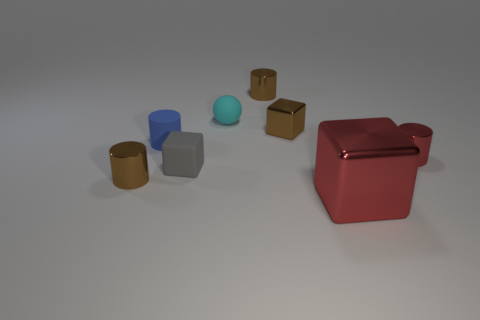Is there anything else that is the same size as the red block?
Give a very brief answer. No. There is a cylinder that is the same color as the large object; what is its size?
Your answer should be very brief. Small. How many other things are the same size as the red block?
Make the answer very short. 0. What color is the tiny metal cylinder left of the sphere?
Ensure brevity in your answer.  Brown. Is the material of the blue object left of the red shiny cylinder the same as the large red cube?
Provide a short and direct response. No. What number of cubes are in front of the tiny red metallic object and on the left side of the big red object?
Keep it short and to the point. 1. There is a metallic block in front of the metal object on the left side of the gray matte block in front of the tiny red thing; what color is it?
Provide a succinct answer. Red. How many other objects are there of the same shape as the blue thing?
Make the answer very short. 3. Is there a small brown cylinder in front of the tiny rubber object that is in front of the red cylinder?
Make the answer very short. Yes. How many matte objects are either red cubes or tiny red things?
Your answer should be compact. 0. 